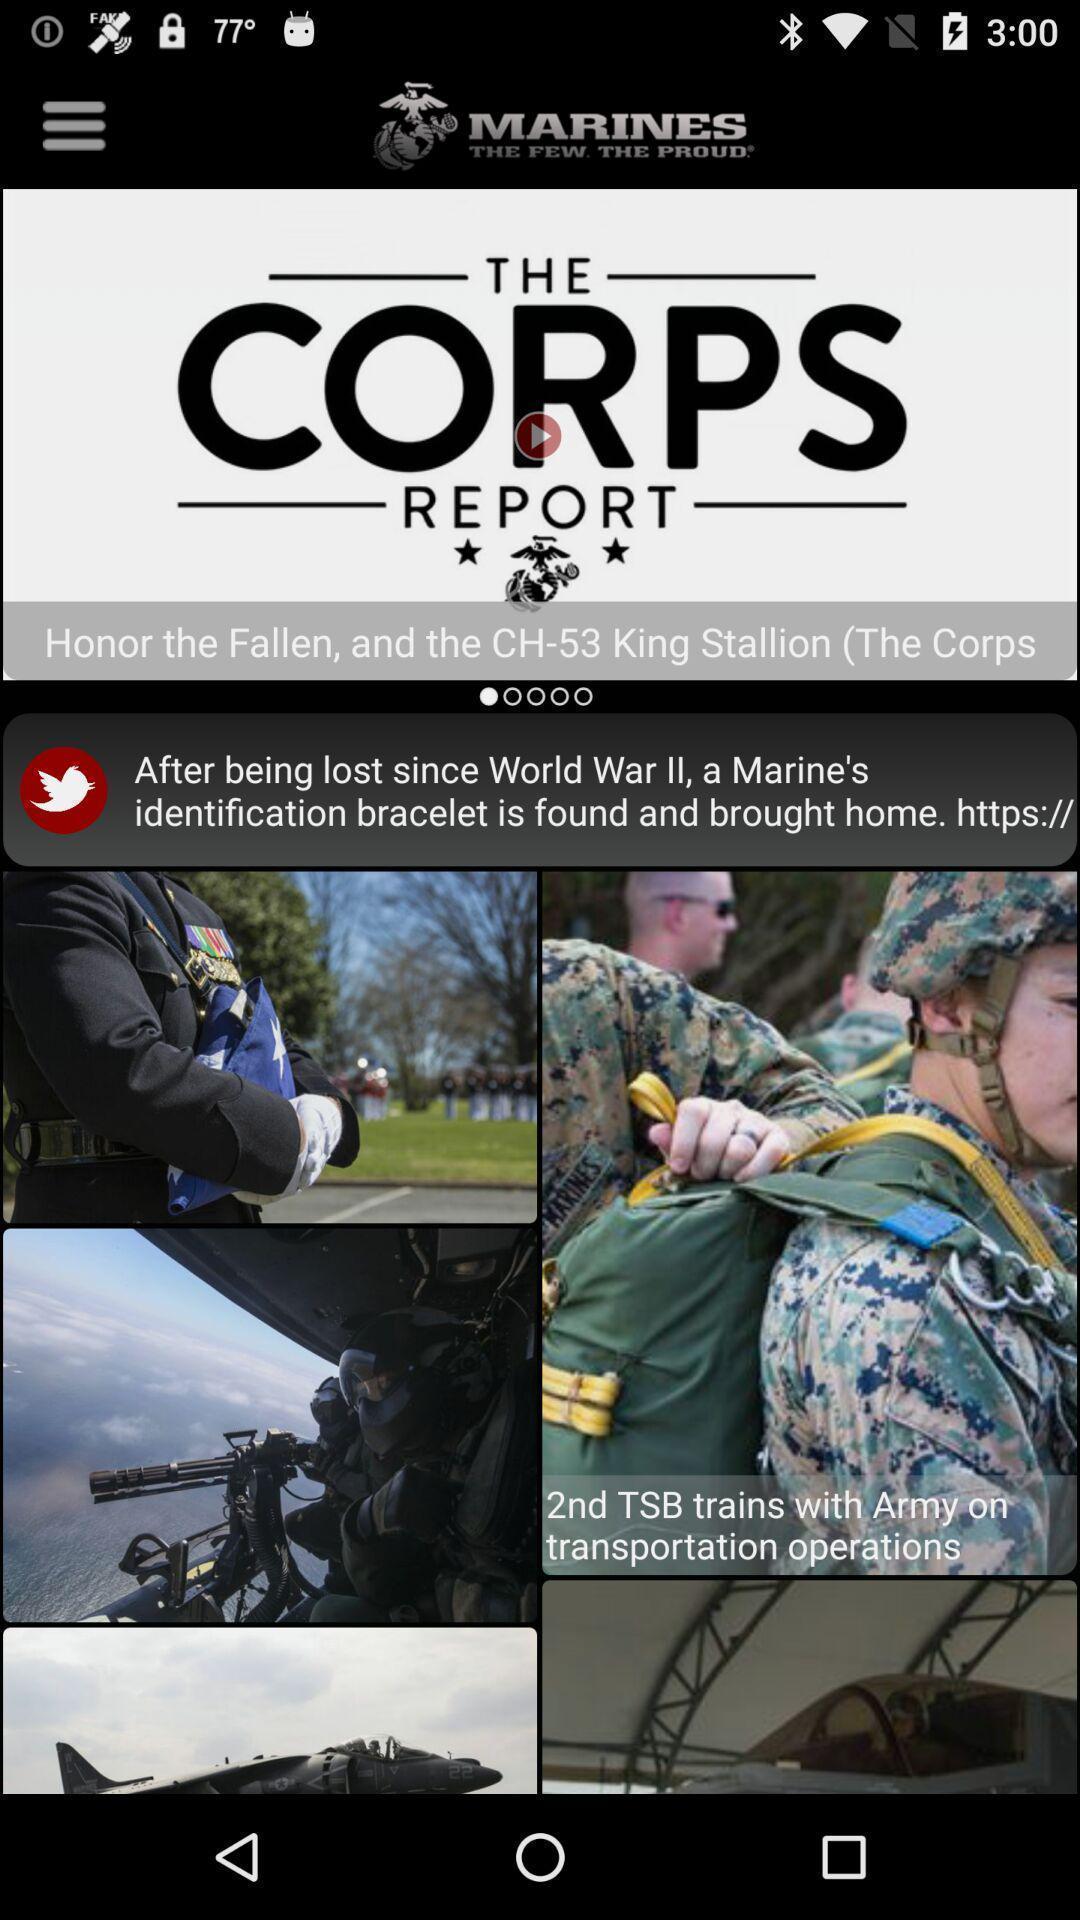Provide a textual representation of this image. Page displays news in news app. 